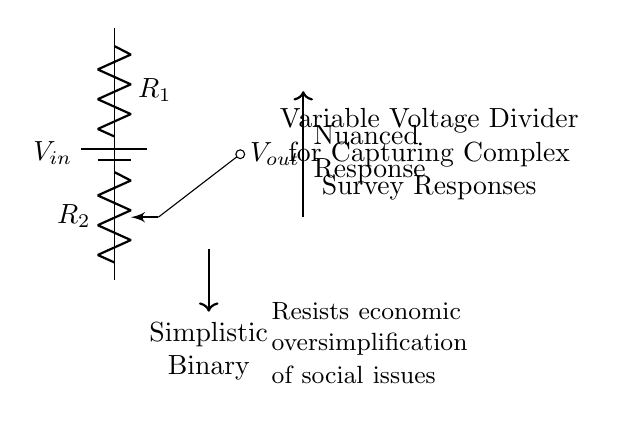What is the input voltage of this circuit? The input voltage, labeled as Vin, is provided by the battery in the circuit diagram. It represents the voltage that is supplied to the voltage divider.
Answer: Vin What component is used to adjust the output voltage? The component used to adjust the output voltage is a potentiometer (R2). A potentiometer allows for varying the resistance and hence can change the voltage output by adjusting its position.
Answer: Potentiometer What do the arrows in the diagram represent? The arrows indicate the direction of influence or flow: one arrow points towards the nuanced response, indicating the output voltage derived from the circuit, while another points downward, representing a more simplistic binary response.
Answer: Direction of influence How many resistances are present in this circuit? There are two resistances in the circuit: one is a fixed resistor (R1), and the other is a variable resistor (R2 or potentiometer).
Answer: Two What is the purpose of this voltage divider in the context of the survey? The purpose of the voltage divider is to capture nuanced survey responses by converting a range of input variations into a proportional output voltage that can reflect complex opinions rather than simplistic values.
Answer: Capture nuanced responses What does Vout stand for in the context of this circuit? Vout stands for the output voltage, which is taken from the wiper of the potentiometer and is a measure of the voltage that corresponds to the varying resistance set by the potentiometer.
Answer: Output voltage What type of responses does this voltage divider help to avoid? This voltage divider helps to avoid simplistic binary responses by allowing for a more continuous range of output that can represent a spectrum of opinions rather than just two options.
Answer: Simplistic binary responses 